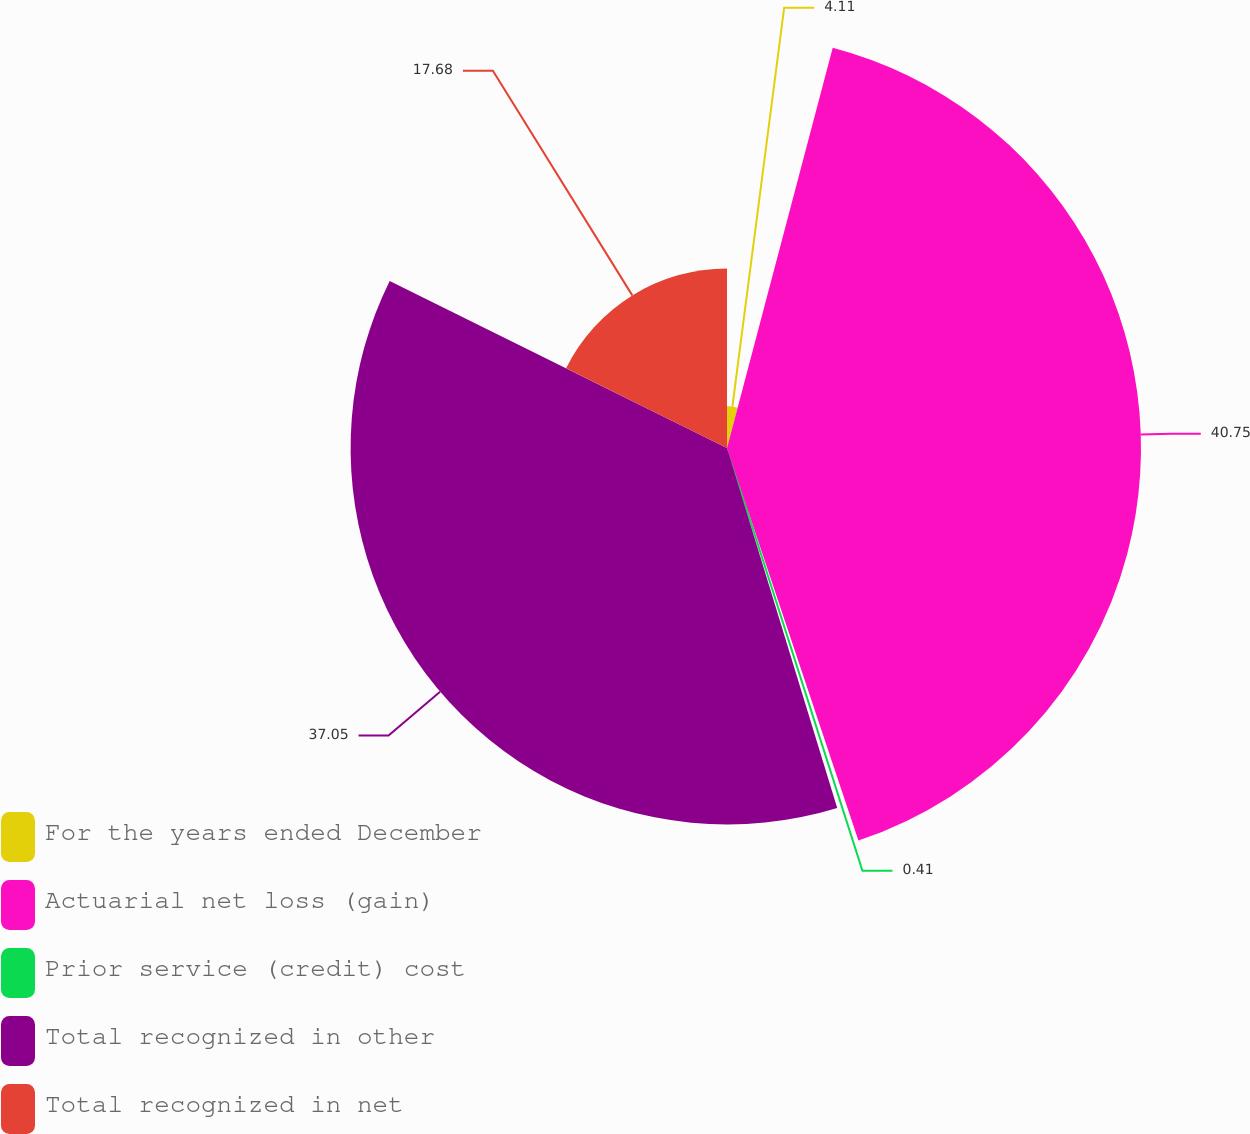<chart> <loc_0><loc_0><loc_500><loc_500><pie_chart><fcel>For the years ended December<fcel>Actuarial net loss (gain)<fcel>Prior service (credit) cost<fcel>Total recognized in other<fcel>Total recognized in net<nl><fcel>4.11%<fcel>40.75%<fcel>0.41%<fcel>37.05%<fcel>17.68%<nl></chart> 